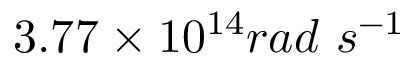Convert formula to latex. <formula><loc_0><loc_0><loc_500><loc_500>3 . 7 7 \times 1 0 ^ { 1 4 } r a d \ s ^ { - 1 }</formula> 